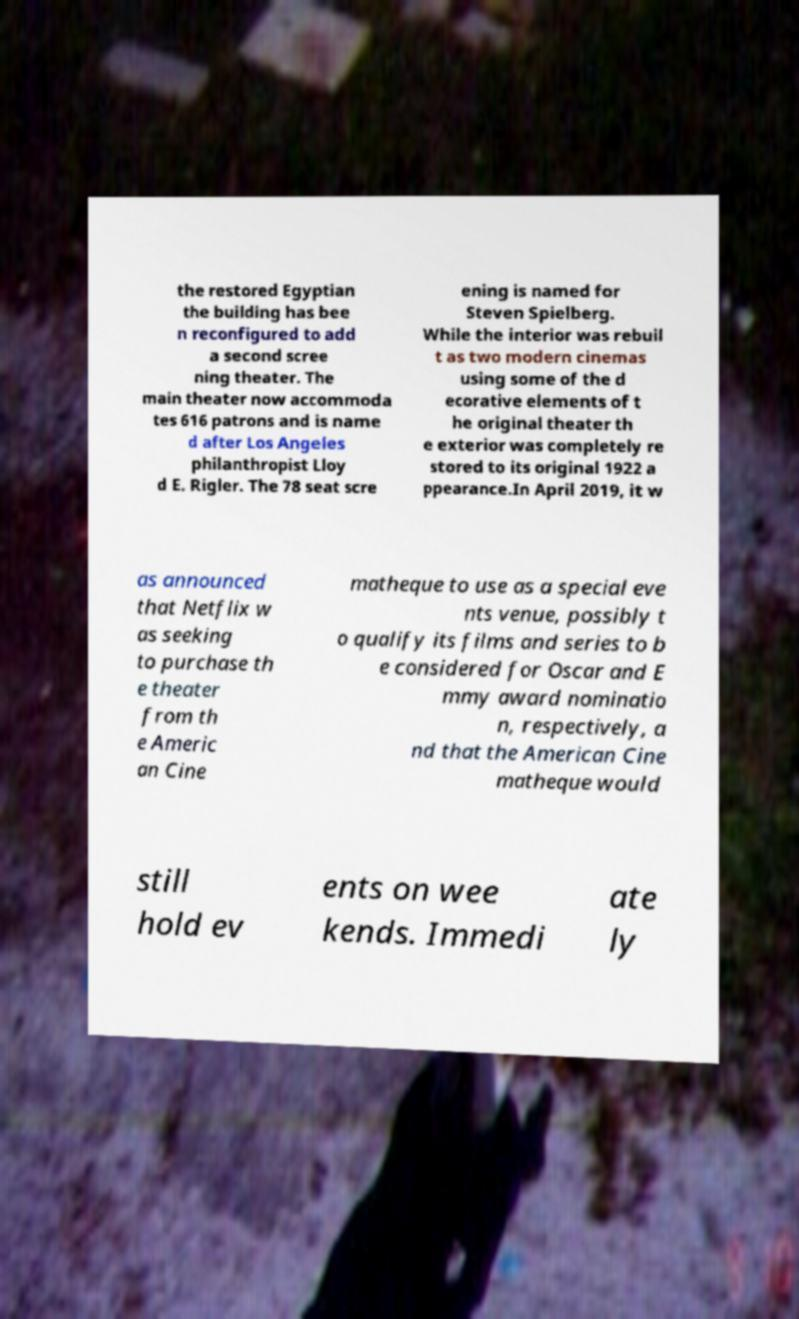Can you accurately transcribe the text from the provided image for me? the restored Egyptian the building has bee n reconfigured to add a second scree ning theater. The main theater now accommoda tes 616 patrons and is name d after Los Angeles philanthropist Lloy d E. Rigler. The 78 seat scre ening is named for Steven Spielberg. While the interior was rebuil t as two modern cinemas using some of the d ecorative elements of t he original theater th e exterior was completely re stored to its original 1922 a ppearance.In April 2019, it w as announced that Netflix w as seeking to purchase th e theater from th e Americ an Cine matheque to use as a special eve nts venue, possibly t o qualify its films and series to b e considered for Oscar and E mmy award nominatio n, respectively, a nd that the American Cine matheque would still hold ev ents on wee kends. Immedi ate ly 